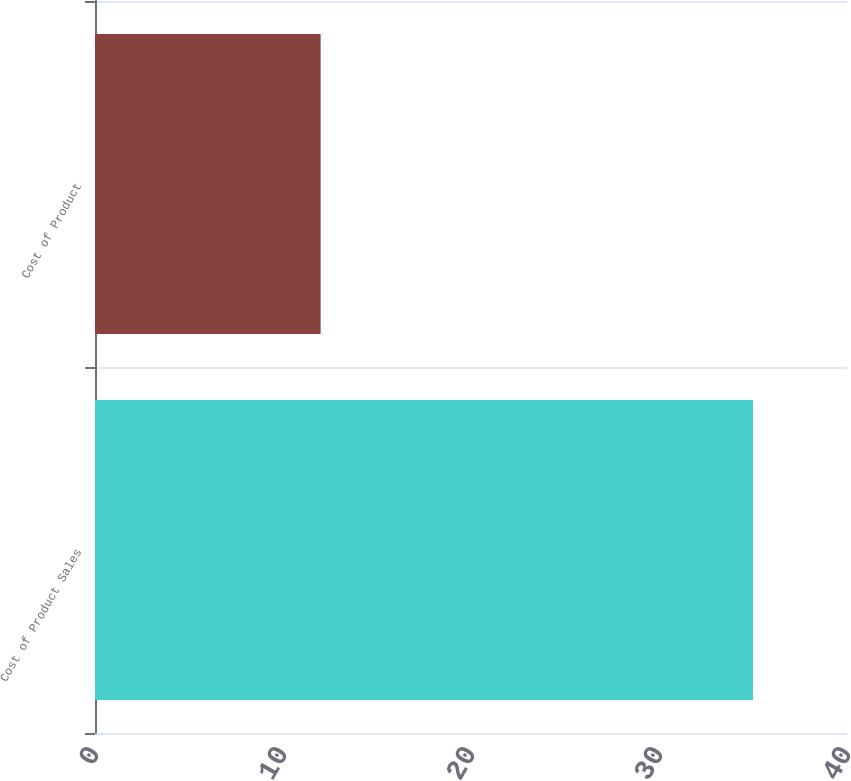Convert chart. <chart><loc_0><loc_0><loc_500><loc_500><bar_chart><fcel>Cost of Product Sales<fcel>Cost of Product<nl><fcel>35<fcel>12<nl></chart> 